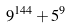<formula> <loc_0><loc_0><loc_500><loc_500>9 ^ { 1 4 4 } + 5 ^ { 9 }</formula> 